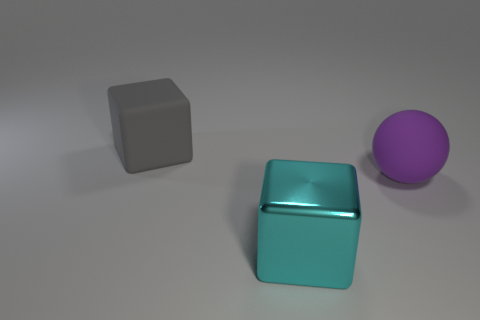There is a cube behind the rubber thing that is on the right side of the big matte cube on the left side of the big metallic thing; how big is it?
Your response must be concise. Large. There is a gray object; is its shape the same as the object that is in front of the large purple object?
Provide a short and direct response. Yes. What number of big things are both to the right of the large cyan block and to the left of the purple matte sphere?
Your answer should be compact. 0. How many blue objects are either large objects or big rubber objects?
Make the answer very short. 0. There is a rubber object that is to the right of the big cube that is on the left side of the big block on the right side of the gray matte cube; what is its color?
Your response must be concise. Purple. There is a large cube behind the big purple object; is there a shiny thing that is behind it?
Offer a terse response. No. There is a rubber thing behind the large purple sphere; is its shape the same as the large cyan metal thing?
Your answer should be very brief. Yes. Is there anything else that is the same shape as the large purple rubber thing?
Your answer should be very brief. No. How many balls are either small gray objects or big gray things?
Ensure brevity in your answer.  0. How many tiny metal cubes are there?
Your answer should be compact. 0. 